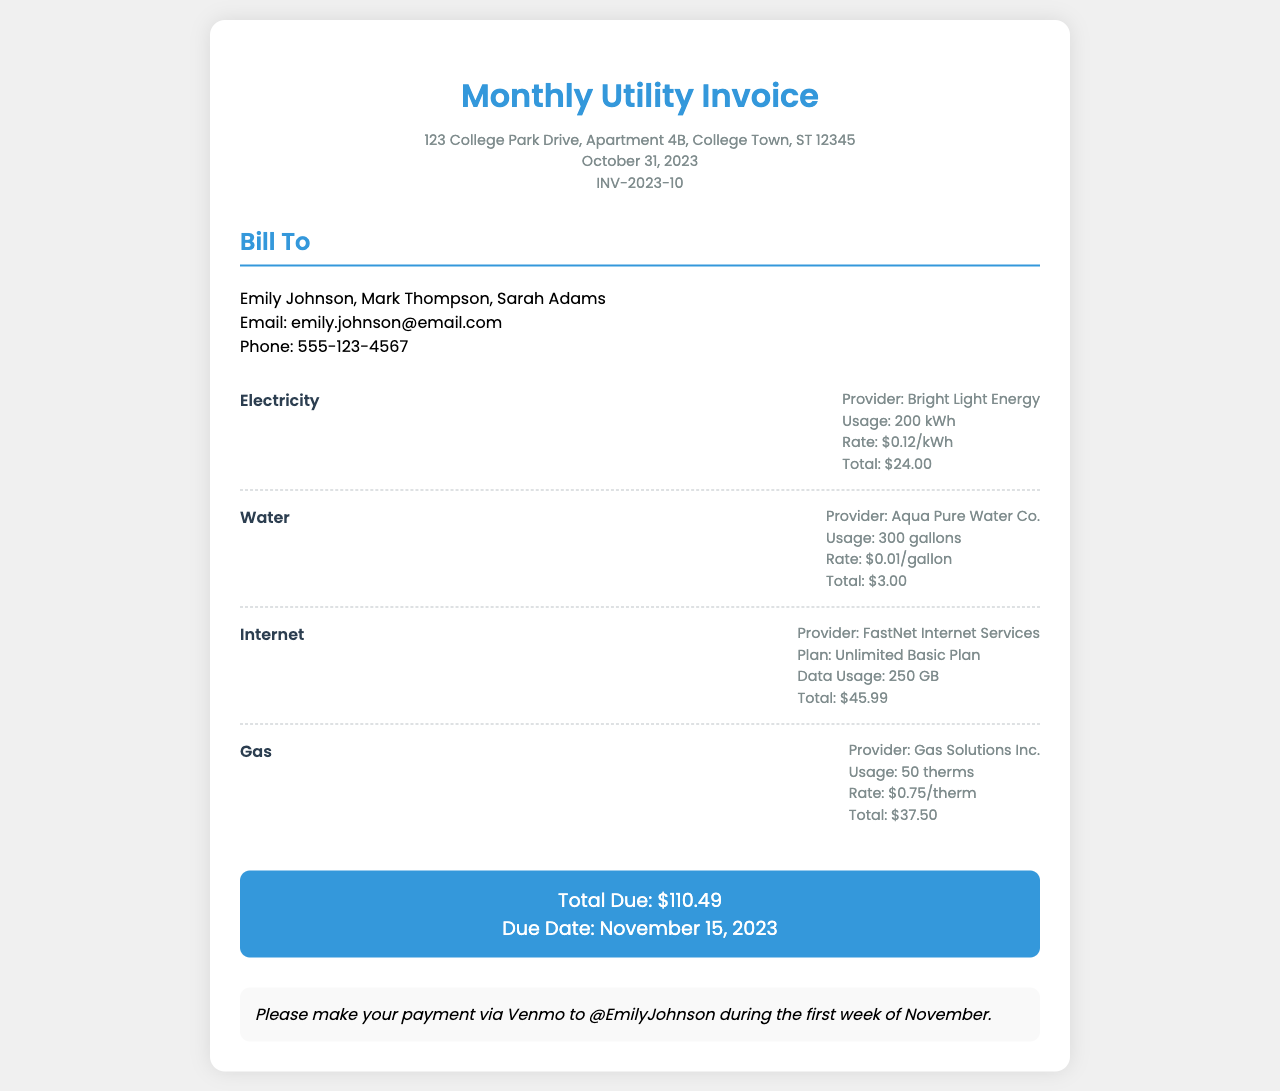What is the total amount due? The total amount due is clearly stated in the document as $110.49.
Answer: $110.49 Who is the electricity provider? The provider for electricity is listed as Bright Light Energy.
Answer: Bright Light Energy What is the usage for water? The document states that the water usage is 300 gallons.
Answer: 300 gallons When is the due date for the payment? The due date for the payment is specified as November 15, 2023.
Answer: November 15, 2023 How much is charged per kilowatt-hour of electricity? The rate for electricity is mentioned as $0.12 per kilowatt-hour.
Answer: $0.12/kWh What is the total cost for gas? The total cost for gas is detailed as $37.50 in the invoice.
Answer: $37.50 Which internet plan is mentioned in the document? The plan for internet service is referred to as Unlimited Basic Plan.
Answer: Unlimited Basic Plan How many roommates are listed on the invoice? The invoice mentions three roommates: Emily Johnson, Mark Thompson, and Sarah Adams.
Answer: Three What is the data usage for internet? The document specifies that the data usage for internet is 250 GB.
Answer: 250 GB What payment method is suggested? The suggested payment method in the document is Venmo to @EmilyJohnson.
Answer: Venmo to @EmilyJohnson 